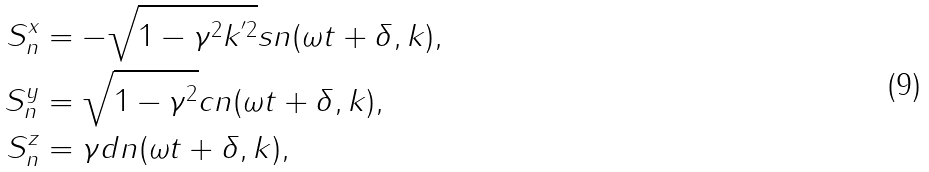Convert formula to latex. <formula><loc_0><loc_0><loc_500><loc_500>S ^ { x } _ { n } & = - \sqrt { 1 - \gamma ^ { 2 } k ^ { ^ { \prime } 2 } } s n ( \omega { t } + \delta , k ) , \\ S ^ { y } _ { n } & = \sqrt { 1 - \gamma ^ { 2 } } c n ( \omega { t } + \delta , k ) , \\ S ^ { z } _ { n } & = \gamma d n ( \omega { t } + \delta , k ) ,</formula> 